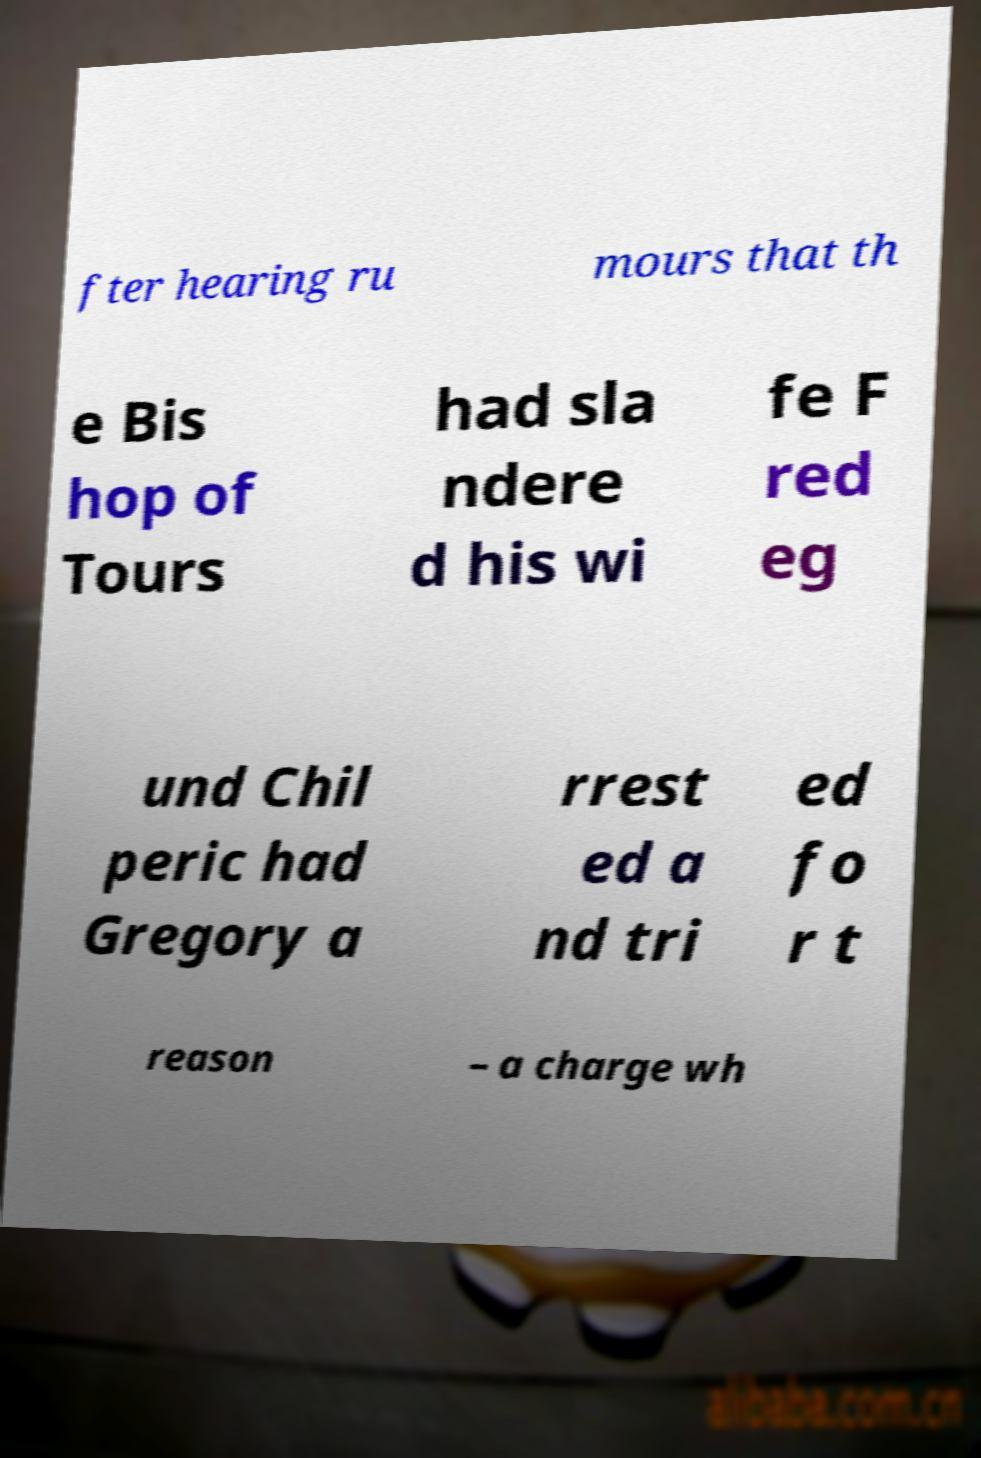Could you extract and type out the text from this image? fter hearing ru mours that th e Bis hop of Tours had sla ndere d his wi fe F red eg und Chil peric had Gregory a rrest ed a nd tri ed fo r t reason – a charge wh 